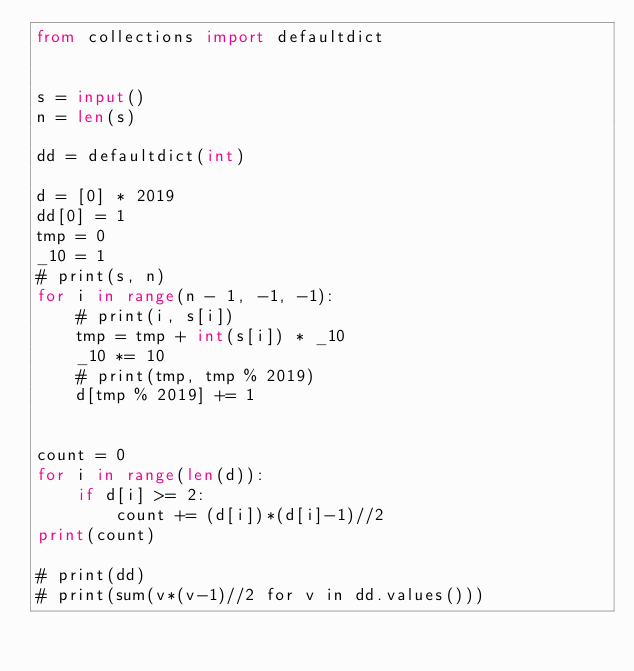<code> <loc_0><loc_0><loc_500><loc_500><_Python_>from collections import defaultdict


s = input()
n = len(s)

dd = defaultdict(int)

d = [0] * 2019
dd[0] = 1
tmp = 0
_10 = 1
# print(s, n)
for i in range(n - 1, -1, -1):
    # print(i, s[i])
    tmp = tmp + int(s[i]) * _10
    _10 *= 10
    # print(tmp, tmp % 2019)
    d[tmp % 2019] += 1


count = 0
for i in range(len(d)):
    if d[i] >= 2:
        count += (d[i])*(d[i]-1)//2
print(count)

# print(dd)
# print(sum(v*(v-1)//2 for v in dd.values()))
</code> 